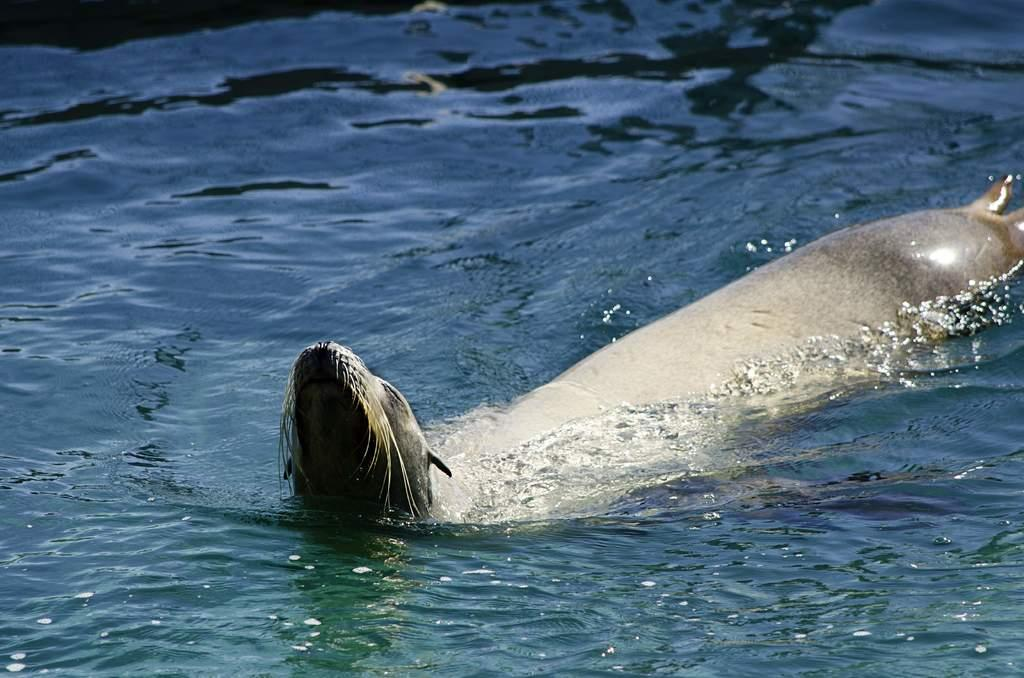What type of animal can be seen in the image? There is a seal in the water in the image. Where is the seal located in the image? The seal is in the water in the image. How many legs can be seen on the seal in the image? Seals do not have legs; they have flippers. However, since the seal is in the water, no limbs are visible in the image. 